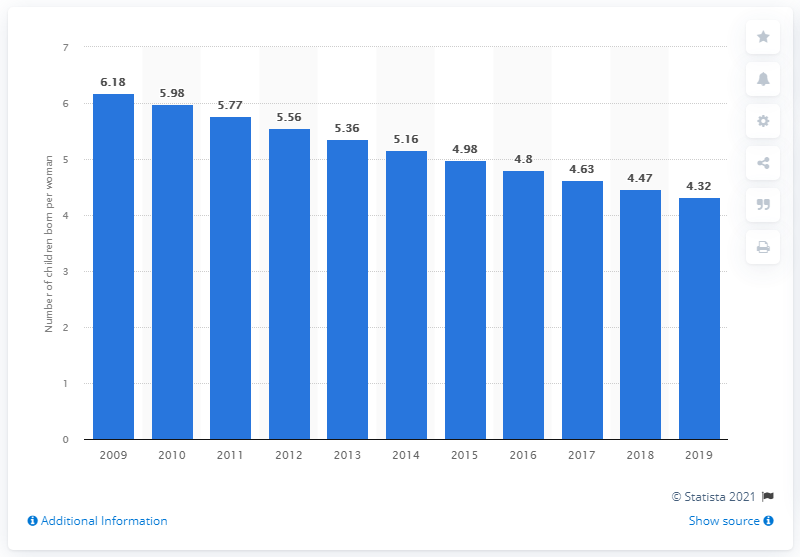Indicate a few pertinent items in this graphic. In 2019, Afghanistan's fertility rate was 4.32 births per woman. 